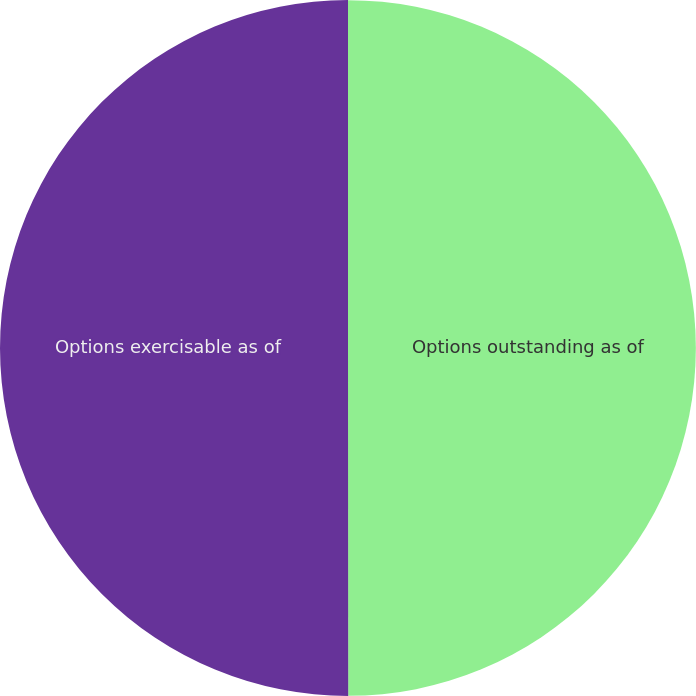Convert chart to OTSL. <chart><loc_0><loc_0><loc_500><loc_500><pie_chart><fcel>Options outstanding as of<fcel>Options exercisable as of<nl><fcel>49.99%<fcel>50.01%<nl></chart> 